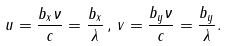<formula> <loc_0><loc_0><loc_500><loc_500>u = \frac { b _ { x } \nu } { c } = \frac { b _ { x } } { \lambda } \, , \, v = \frac { b _ { y } \nu } { c } = \frac { b _ { y } } { \lambda } .</formula> 